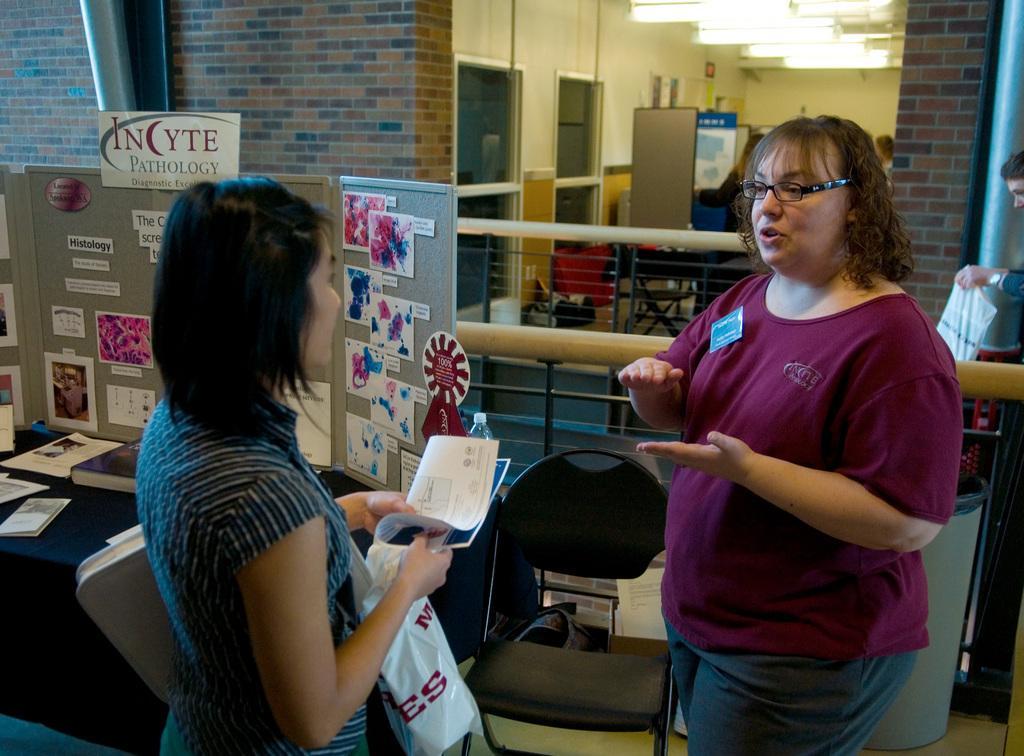Can you describe this image briefly? In this image there are two persons standing in middle of this image and there is one another person standing at right side of this image is holding a clover and the left side person is holding a handbag and some papers. there is a wall in the background. There is a chair at bottom of this image and and there are some boards at left side of this image and there are are some books kept on the table which is at bottom left corner. There are some lights at top of this image and there are some doors as we can see at top of this image. 